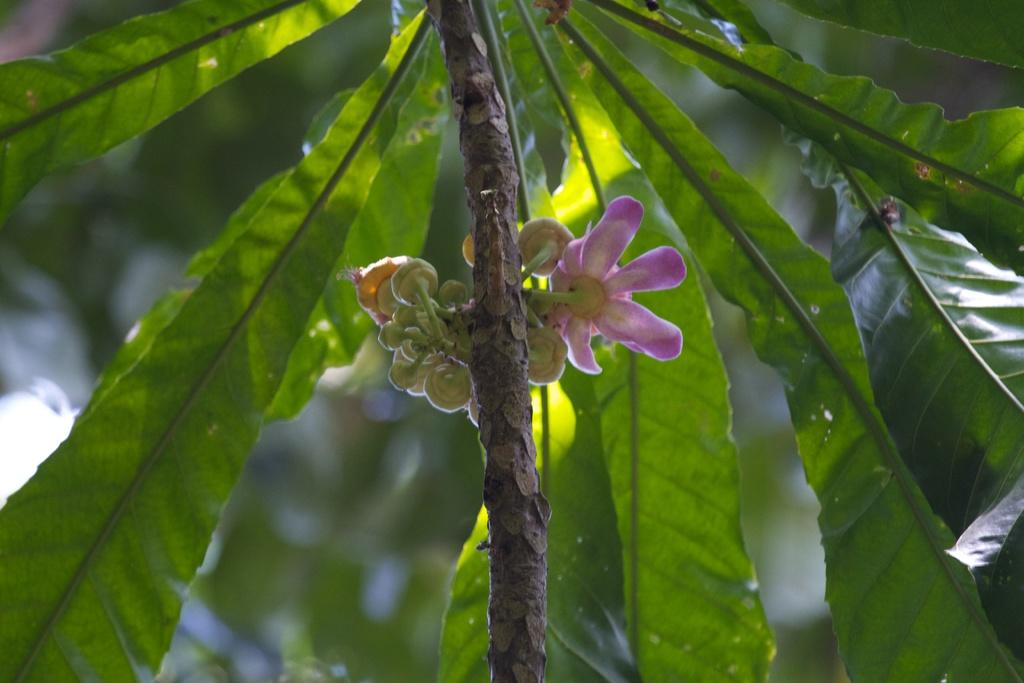What type of living organisms can be seen in the image? There are flowers in the image. What stage of growth can be observed on the plant in the image? There are buds on a plant in the image. Can you describe the background of the image? The background of the image is blurred. What type of honey is being collected by the monkey in the image? There is no monkey or honey present in the image; it features flowers and a blurred background. 